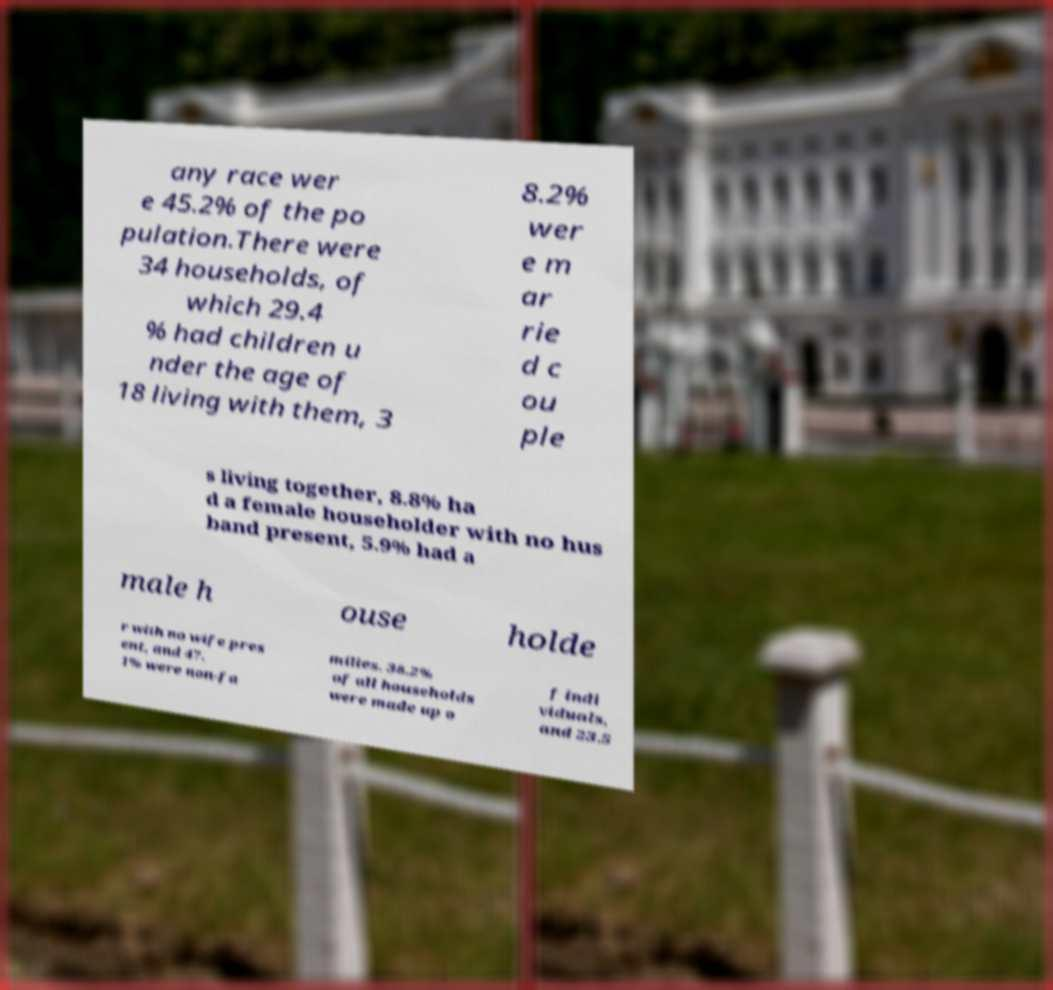Can you accurately transcribe the text from the provided image for me? any race wer e 45.2% of the po pulation.There were 34 households, of which 29.4 % had children u nder the age of 18 living with them, 3 8.2% wer e m ar rie d c ou ple s living together, 8.8% ha d a female householder with no hus band present, 5.9% had a male h ouse holde r with no wife pres ent, and 47. 1% were non-fa milies. 38.2% of all households were made up o f indi viduals, and 23.5 